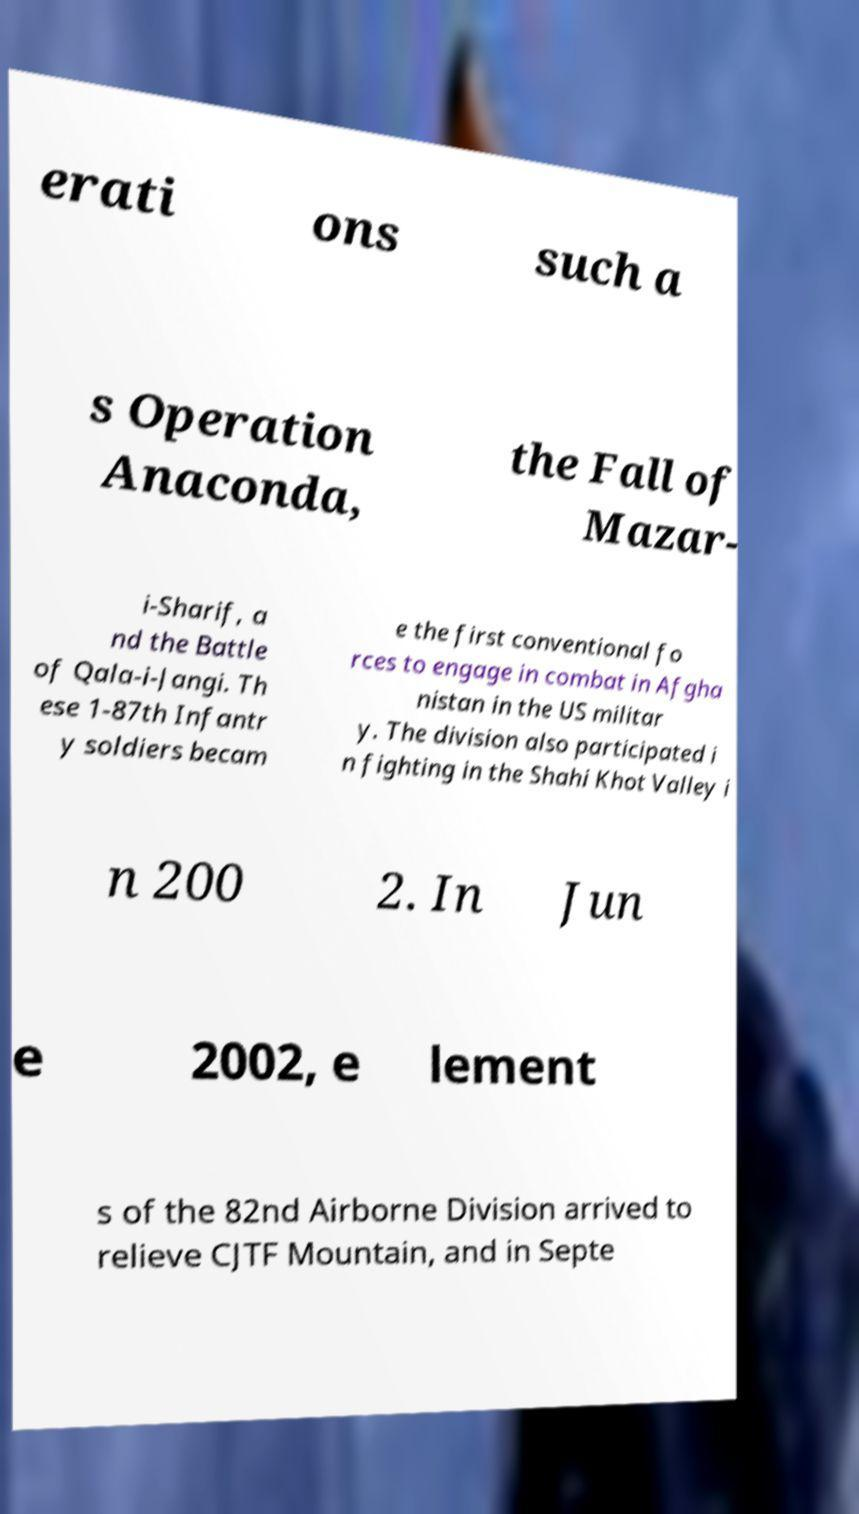Could you extract and type out the text from this image? erati ons such a s Operation Anaconda, the Fall of Mazar- i-Sharif, a nd the Battle of Qala-i-Jangi. Th ese 1-87th Infantr y soldiers becam e the first conventional fo rces to engage in combat in Afgha nistan in the US militar y. The division also participated i n fighting in the Shahi Khot Valley i n 200 2. In Jun e 2002, e lement s of the 82nd Airborne Division arrived to relieve CJTF Mountain, and in Septe 